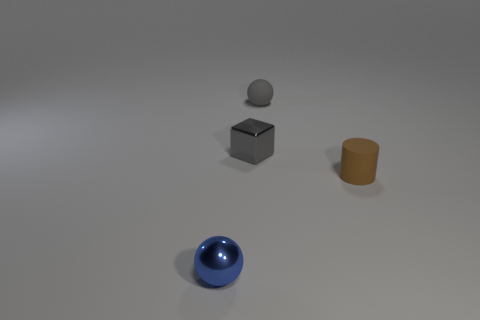Are there any signs of wear or usage on these objects that could tell a story? The objects look pristine, without any visible scratches, dents, or signs of wear. This tells us they are likely new or have been well-maintained, and possibly that they are meant for display purposes, rather than functional use. 